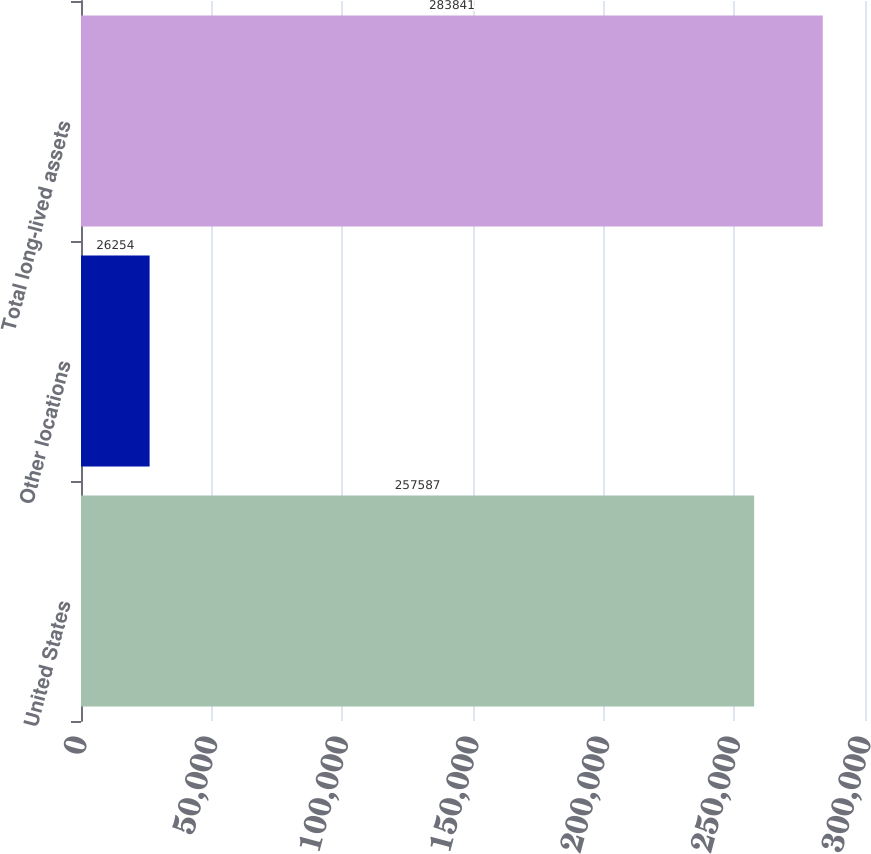Convert chart. <chart><loc_0><loc_0><loc_500><loc_500><bar_chart><fcel>United States<fcel>Other locations<fcel>Total long-lived assets<nl><fcel>257587<fcel>26254<fcel>283841<nl></chart> 